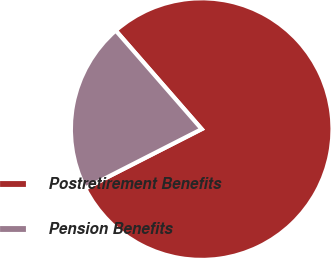Convert chart to OTSL. <chart><loc_0><loc_0><loc_500><loc_500><pie_chart><fcel>Postretirement Benefits<fcel>Pension Benefits<nl><fcel>78.91%<fcel>21.09%<nl></chart> 